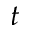Convert formula to latex. <formula><loc_0><loc_0><loc_500><loc_500>t</formula> 